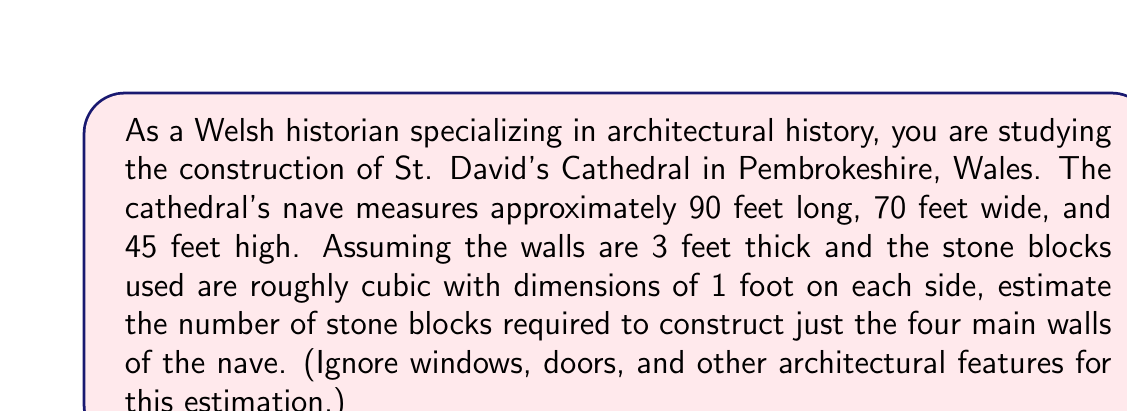Could you help me with this problem? To solve this problem, we need to calculate the volume of stone required for the walls and divide it by the volume of each stone block. Let's break it down step-by-step:

1. Calculate the surface area of the walls:
   - Long walls: $2 \times 90 \text{ ft} \times 45 \text{ ft} = 8,100 \text{ sq ft}$
   - Short walls: $2 \times 70 \text{ ft} \times 45 \text{ ft} = 6,300 \text{ sq ft}$
   - Total surface area: $8,100 + 6,300 = 14,400 \text{ sq ft}$

2. Calculate the volume of stone needed:
   - Volume = Surface area × Wall thickness
   - $V = 14,400 \text{ sq ft} \times 3 \text{ ft} = 43,200 \text{ cu ft}$

3. Calculate the volume of each stone block:
   - Each block is 1 ft × 1 ft × 1 ft = 1 cu ft

4. Estimate the number of blocks:
   - Number of blocks = Volume of stone needed ÷ Volume of each block
   - $N = \frac{43,200 \text{ cu ft}}{1 \text{ cu ft/block}} = 43,200 \text{ blocks}$

Therefore, approximately 43,200 stone blocks would be required to construct the main walls of the nave.
Answer: Approximately 43,200 stone blocks 